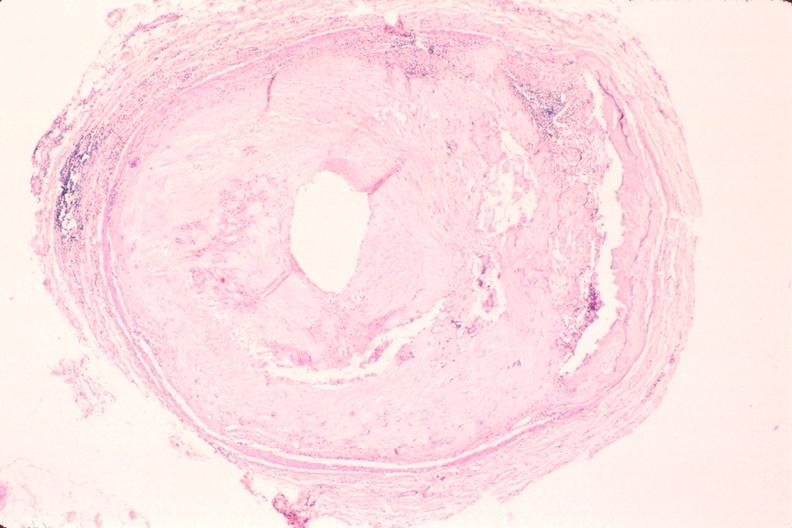s abdomen present?
Answer the question using a single word or phrase. No 